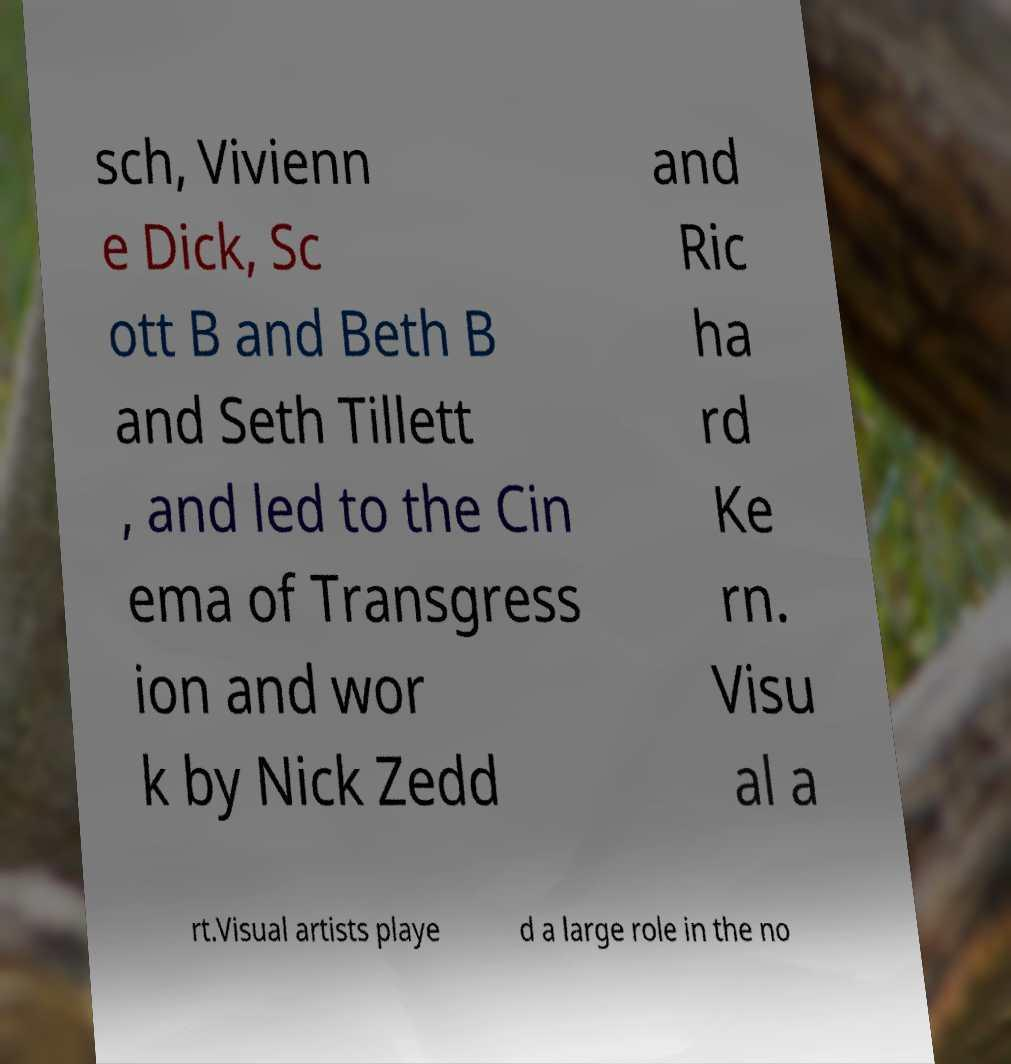There's text embedded in this image that I need extracted. Can you transcribe it verbatim? sch, Vivienn e Dick, Sc ott B and Beth B and Seth Tillett , and led to the Cin ema of Transgress ion and wor k by Nick Zedd and Ric ha rd Ke rn. Visu al a rt.Visual artists playe d a large role in the no 